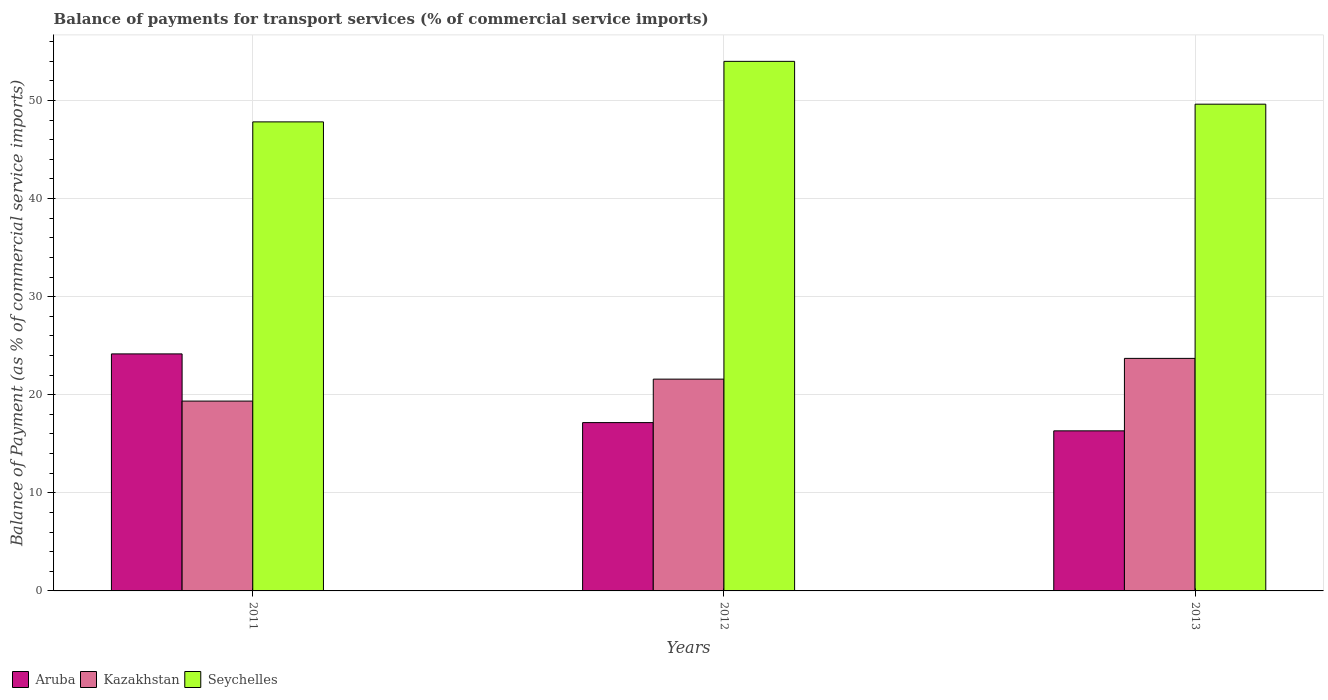How many groups of bars are there?
Offer a terse response. 3. Are the number of bars per tick equal to the number of legend labels?
Keep it short and to the point. Yes. How many bars are there on the 2nd tick from the left?
Make the answer very short. 3. In how many cases, is the number of bars for a given year not equal to the number of legend labels?
Ensure brevity in your answer.  0. What is the balance of payments for transport services in Seychelles in 2011?
Provide a short and direct response. 47.81. Across all years, what is the maximum balance of payments for transport services in Kazakhstan?
Provide a succinct answer. 23.7. Across all years, what is the minimum balance of payments for transport services in Kazakhstan?
Provide a succinct answer. 19.35. What is the total balance of payments for transport services in Seychelles in the graph?
Make the answer very short. 151.41. What is the difference between the balance of payments for transport services in Aruba in 2011 and that in 2012?
Your answer should be compact. 7. What is the difference between the balance of payments for transport services in Kazakhstan in 2011 and the balance of payments for transport services in Aruba in 2012?
Give a very brief answer. 2.19. What is the average balance of payments for transport services in Seychelles per year?
Ensure brevity in your answer.  50.47. In the year 2012, what is the difference between the balance of payments for transport services in Kazakhstan and balance of payments for transport services in Aruba?
Keep it short and to the point. 4.43. What is the ratio of the balance of payments for transport services in Aruba in 2011 to that in 2013?
Make the answer very short. 1.48. Is the balance of payments for transport services in Seychelles in 2011 less than that in 2013?
Provide a succinct answer. Yes. Is the difference between the balance of payments for transport services in Kazakhstan in 2012 and 2013 greater than the difference between the balance of payments for transport services in Aruba in 2012 and 2013?
Your response must be concise. No. What is the difference between the highest and the second highest balance of payments for transport services in Aruba?
Your answer should be very brief. 7. What is the difference between the highest and the lowest balance of payments for transport services in Seychelles?
Provide a short and direct response. 6.17. In how many years, is the balance of payments for transport services in Kazakhstan greater than the average balance of payments for transport services in Kazakhstan taken over all years?
Provide a short and direct response. 2. What does the 3rd bar from the left in 2011 represents?
Offer a very short reply. Seychelles. What does the 3rd bar from the right in 2013 represents?
Offer a terse response. Aruba. Is it the case that in every year, the sum of the balance of payments for transport services in Kazakhstan and balance of payments for transport services in Aruba is greater than the balance of payments for transport services in Seychelles?
Offer a very short reply. No. Are all the bars in the graph horizontal?
Give a very brief answer. No. What is the difference between two consecutive major ticks on the Y-axis?
Your answer should be compact. 10. Are the values on the major ticks of Y-axis written in scientific E-notation?
Your answer should be very brief. No. Does the graph contain any zero values?
Provide a succinct answer. No. Where does the legend appear in the graph?
Give a very brief answer. Bottom left. How many legend labels are there?
Your answer should be very brief. 3. What is the title of the graph?
Provide a short and direct response. Balance of payments for transport services (% of commercial service imports). Does "Channel Islands" appear as one of the legend labels in the graph?
Give a very brief answer. No. What is the label or title of the Y-axis?
Offer a very short reply. Balance of Payment (as % of commercial service imports). What is the Balance of Payment (as % of commercial service imports) in Aruba in 2011?
Keep it short and to the point. 24.16. What is the Balance of Payment (as % of commercial service imports) of Kazakhstan in 2011?
Provide a succinct answer. 19.35. What is the Balance of Payment (as % of commercial service imports) in Seychelles in 2011?
Ensure brevity in your answer.  47.81. What is the Balance of Payment (as % of commercial service imports) of Aruba in 2012?
Offer a very short reply. 17.16. What is the Balance of Payment (as % of commercial service imports) in Kazakhstan in 2012?
Give a very brief answer. 21.59. What is the Balance of Payment (as % of commercial service imports) in Seychelles in 2012?
Your answer should be compact. 53.98. What is the Balance of Payment (as % of commercial service imports) in Aruba in 2013?
Give a very brief answer. 16.32. What is the Balance of Payment (as % of commercial service imports) in Kazakhstan in 2013?
Your answer should be compact. 23.7. What is the Balance of Payment (as % of commercial service imports) of Seychelles in 2013?
Give a very brief answer. 49.62. Across all years, what is the maximum Balance of Payment (as % of commercial service imports) in Aruba?
Offer a terse response. 24.16. Across all years, what is the maximum Balance of Payment (as % of commercial service imports) in Kazakhstan?
Your answer should be compact. 23.7. Across all years, what is the maximum Balance of Payment (as % of commercial service imports) of Seychelles?
Provide a succinct answer. 53.98. Across all years, what is the minimum Balance of Payment (as % of commercial service imports) of Aruba?
Your answer should be very brief. 16.32. Across all years, what is the minimum Balance of Payment (as % of commercial service imports) in Kazakhstan?
Offer a terse response. 19.35. Across all years, what is the minimum Balance of Payment (as % of commercial service imports) in Seychelles?
Your response must be concise. 47.81. What is the total Balance of Payment (as % of commercial service imports) in Aruba in the graph?
Your response must be concise. 57.64. What is the total Balance of Payment (as % of commercial service imports) in Kazakhstan in the graph?
Your answer should be compact. 64.65. What is the total Balance of Payment (as % of commercial service imports) in Seychelles in the graph?
Offer a very short reply. 151.41. What is the difference between the Balance of Payment (as % of commercial service imports) in Aruba in 2011 and that in 2012?
Give a very brief answer. 7. What is the difference between the Balance of Payment (as % of commercial service imports) of Kazakhstan in 2011 and that in 2012?
Offer a terse response. -2.24. What is the difference between the Balance of Payment (as % of commercial service imports) in Seychelles in 2011 and that in 2012?
Ensure brevity in your answer.  -6.17. What is the difference between the Balance of Payment (as % of commercial service imports) in Aruba in 2011 and that in 2013?
Offer a terse response. 7.84. What is the difference between the Balance of Payment (as % of commercial service imports) in Kazakhstan in 2011 and that in 2013?
Ensure brevity in your answer.  -4.35. What is the difference between the Balance of Payment (as % of commercial service imports) in Seychelles in 2011 and that in 2013?
Offer a terse response. -1.8. What is the difference between the Balance of Payment (as % of commercial service imports) in Aruba in 2012 and that in 2013?
Give a very brief answer. 0.84. What is the difference between the Balance of Payment (as % of commercial service imports) in Kazakhstan in 2012 and that in 2013?
Make the answer very short. -2.12. What is the difference between the Balance of Payment (as % of commercial service imports) in Seychelles in 2012 and that in 2013?
Provide a succinct answer. 4.37. What is the difference between the Balance of Payment (as % of commercial service imports) in Aruba in 2011 and the Balance of Payment (as % of commercial service imports) in Kazakhstan in 2012?
Your response must be concise. 2.57. What is the difference between the Balance of Payment (as % of commercial service imports) in Aruba in 2011 and the Balance of Payment (as % of commercial service imports) in Seychelles in 2012?
Provide a succinct answer. -29.82. What is the difference between the Balance of Payment (as % of commercial service imports) of Kazakhstan in 2011 and the Balance of Payment (as % of commercial service imports) of Seychelles in 2012?
Your answer should be very brief. -34.63. What is the difference between the Balance of Payment (as % of commercial service imports) of Aruba in 2011 and the Balance of Payment (as % of commercial service imports) of Kazakhstan in 2013?
Your answer should be very brief. 0.46. What is the difference between the Balance of Payment (as % of commercial service imports) in Aruba in 2011 and the Balance of Payment (as % of commercial service imports) in Seychelles in 2013?
Your answer should be very brief. -25.46. What is the difference between the Balance of Payment (as % of commercial service imports) of Kazakhstan in 2011 and the Balance of Payment (as % of commercial service imports) of Seychelles in 2013?
Offer a very short reply. -30.27. What is the difference between the Balance of Payment (as % of commercial service imports) of Aruba in 2012 and the Balance of Payment (as % of commercial service imports) of Kazakhstan in 2013?
Provide a succinct answer. -6.55. What is the difference between the Balance of Payment (as % of commercial service imports) in Aruba in 2012 and the Balance of Payment (as % of commercial service imports) in Seychelles in 2013?
Offer a terse response. -32.46. What is the difference between the Balance of Payment (as % of commercial service imports) in Kazakhstan in 2012 and the Balance of Payment (as % of commercial service imports) in Seychelles in 2013?
Your answer should be very brief. -28.03. What is the average Balance of Payment (as % of commercial service imports) in Aruba per year?
Give a very brief answer. 19.21. What is the average Balance of Payment (as % of commercial service imports) in Kazakhstan per year?
Keep it short and to the point. 21.55. What is the average Balance of Payment (as % of commercial service imports) of Seychelles per year?
Offer a very short reply. 50.47. In the year 2011, what is the difference between the Balance of Payment (as % of commercial service imports) of Aruba and Balance of Payment (as % of commercial service imports) of Kazakhstan?
Offer a very short reply. 4.81. In the year 2011, what is the difference between the Balance of Payment (as % of commercial service imports) in Aruba and Balance of Payment (as % of commercial service imports) in Seychelles?
Your answer should be very brief. -23.65. In the year 2011, what is the difference between the Balance of Payment (as % of commercial service imports) of Kazakhstan and Balance of Payment (as % of commercial service imports) of Seychelles?
Provide a short and direct response. -28.46. In the year 2012, what is the difference between the Balance of Payment (as % of commercial service imports) of Aruba and Balance of Payment (as % of commercial service imports) of Kazakhstan?
Make the answer very short. -4.43. In the year 2012, what is the difference between the Balance of Payment (as % of commercial service imports) in Aruba and Balance of Payment (as % of commercial service imports) in Seychelles?
Your answer should be very brief. -36.83. In the year 2012, what is the difference between the Balance of Payment (as % of commercial service imports) of Kazakhstan and Balance of Payment (as % of commercial service imports) of Seychelles?
Your answer should be very brief. -32.39. In the year 2013, what is the difference between the Balance of Payment (as % of commercial service imports) in Aruba and Balance of Payment (as % of commercial service imports) in Kazakhstan?
Offer a very short reply. -7.39. In the year 2013, what is the difference between the Balance of Payment (as % of commercial service imports) in Aruba and Balance of Payment (as % of commercial service imports) in Seychelles?
Offer a very short reply. -33.3. In the year 2013, what is the difference between the Balance of Payment (as % of commercial service imports) in Kazakhstan and Balance of Payment (as % of commercial service imports) in Seychelles?
Make the answer very short. -25.91. What is the ratio of the Balance of Payment (as % of commercial service imports) of Aruba in 2011 to that in 2012?
Your answer should be very brief. 1.41. What is the ratio of the Balance of Payment (as % of commercial service imports) of Kazakhstan in 2011 to that in 2012?
Offer a very short reply. 0.9. What is the ratio of the Balance of Payment (as % of commercial service imports) in Seychelles in 2011 to that in 2012?
Provide a short and direct response. 0.89. What is the ratio of the Balance of Payment (as % of commercial service imports) of Aruba in 2011 to that in 2013?
Your answer should be compact. 1.48. What is the ratio of the Balance of Payment (as % of commercial service imports) of Kazakhstan in 2011 to that in 2013?
Provide a succinct answer. 0.82. What is the ratio of the Balance of Payment (as % of commercial service imports) in Seychelles in 2011 to that in 2013?
Your answer should be very brief. 0.96. What is the ratio of the Balance of Payment (as % of commercial service imports) in Aruba in 2012 to that in 2013?
Your answer should be compact. 1.05. What is the ratio of the Balance of Payment (as % of commercial service imports) in Kazakhstan in 2012 to that in 2013?
Provide a short and direct response. 0.91. What is the ratio of the Balance of Payment (as % of commercial service imports) of Seychelles in 2012 to that in 2013?
Offer a terse response. 1.09. What is the difference between the highest and the second highest Balance of Payment (as % of commercial service imports) in Aruba?
Make the answer very short. 7. What is the difference between the highest and the second highest Balance of Payment (as % of commercial service imports) in Kazakhstan?
Offer a very short reply. 2.12. What is the difference between the highest and the second highest Balance of Payment (as % of commercial service imports) in Seychelles?
Ensure brevity in your answer.  4.37. What is the difference between the highest and the lowest Balance of Payment (as % of commercial service imports) in Aruba?
Offer a very short reply. 7.84. What is the difference between the highest and the lowest Balance of Payment (as % of commercial service imports) of Kazakhstan?
Offer a terse response. 4.35. What is the difference between the highest and the lowest Balance of Payment (as % of commercial service imports) of Seychelles?
Provide a succinct answer. 6.17. 